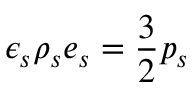Convert formula to latex. <formula><loc_0><loc_0><loc_500><loc_500>\epsilon _ { s } \rho _ { s } e _ { s } = \frac { 3 } { 2 } p _ { s }</formula> 